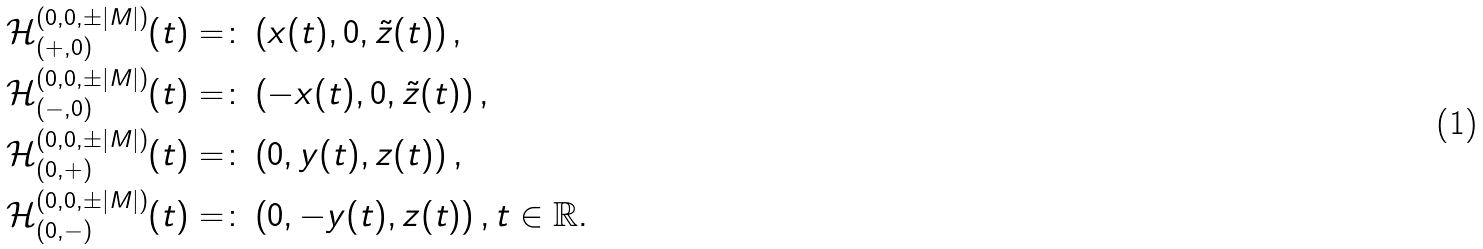<formula> <loc_0><loc_0><loc_500><loc_500>\mathcal { H } _ { ( + , 0 ) } ^ { ( 0 , 0 , \pm | M | ) } ( t ) & = \colon \left ( x ( t ) , 0 , \tilde { z } ( t ) \right ) , \\ \mathcal { H } _ { ( - , 0 ) } ^ { ( 0 , 0 , \pm | M | ) } ( t ) & = \colon \left ( - x ( t ) , 0 , \tilde { z } ( t ) \right ) , \\ \mathcal { H } _ { ( 0 , + ) } ^ { ( 0 , 0 , \pm | M | ) } ( t ) & = \colon \left ( 0 , y ( t ) , z ( t ) \right ) , \\ \mathcal { H } _ { ( 0 , - ) } ^ { ( 0 , 0 , \pm | M | ) } ( t ) & = \colon \left ( 0 , - y ( t ) , z ( t ) \right ) , t \in \mathbb { R } .</formula> 